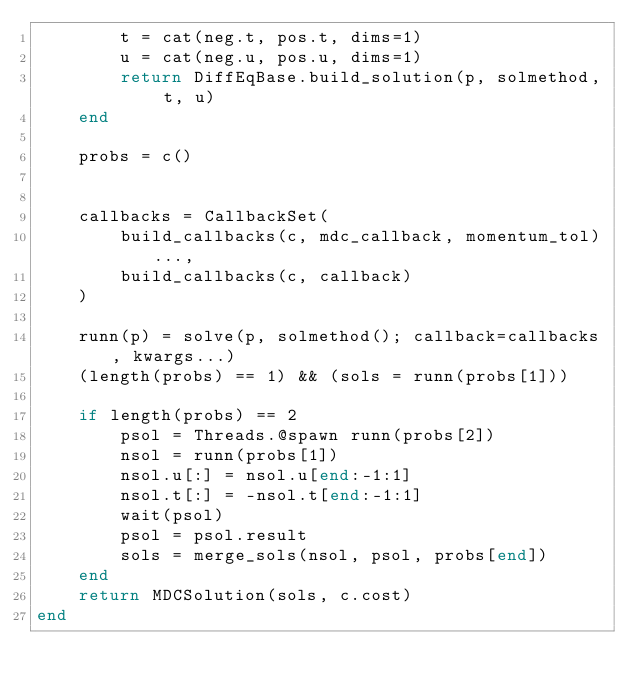<code> <loc_0><loc_0><loc_500><loc_500><_Julia_>        t = cat(neg.t, pos.t, dims=1)
        u = cat(neg.u, pos.u, dims=1)
        return DiffEqBase.build_solution(p, solmethod, t, u)
    end
    
    probs = c()
    

    callbacks = CallbackSet(
        build_callbacks(c, mdc_callback, momentum_tol)...,
        build_callbacks(c, callback)
    )

    runn(p) = solve(p, solmethod(); callback=callbacks, kwargs...)
    (length(probs) == 1) && (sols = runn(probs[1]))

    if length(probs) == 2
        psol = Threads.@spawn runn(probs[2])
        nsol = runn(probs[1])
        nsol.u[:] = nsol.u[end:-1:1]
        nsol.t[:] = -nsol.t[end:-1:1]
        wait(psol)
        psol = psol.result
        sols = merge_sols(nsol, psol, probs[end])
    end
    return MDCSolution(sols, c.cost)
end
</code> 